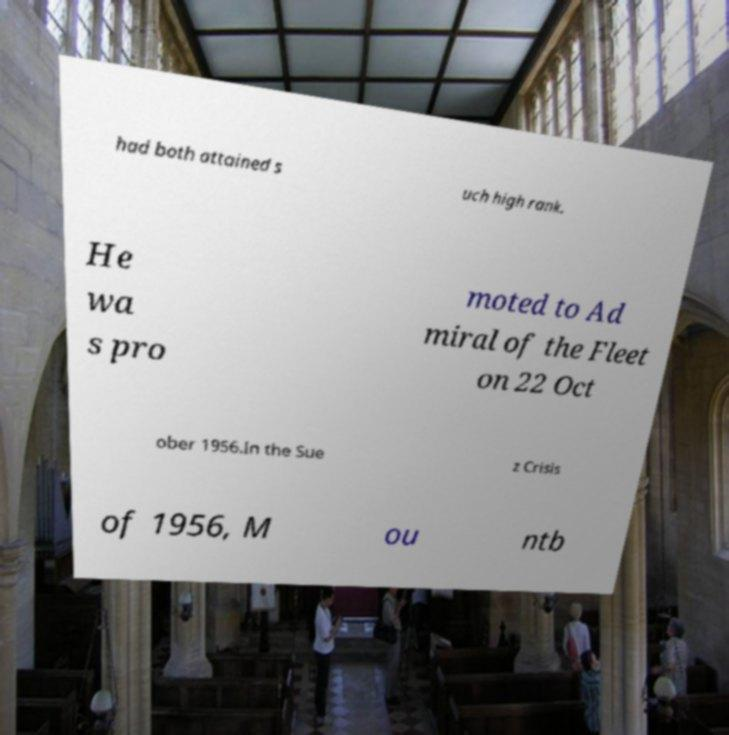Could you extract and type out the text from this image? had both attained s uch high rank. He wa s pro moted to Ad miral of the Fleet on 22 Oct ober 1956.In the Sue z Crisis of 1956, M ou ntb 